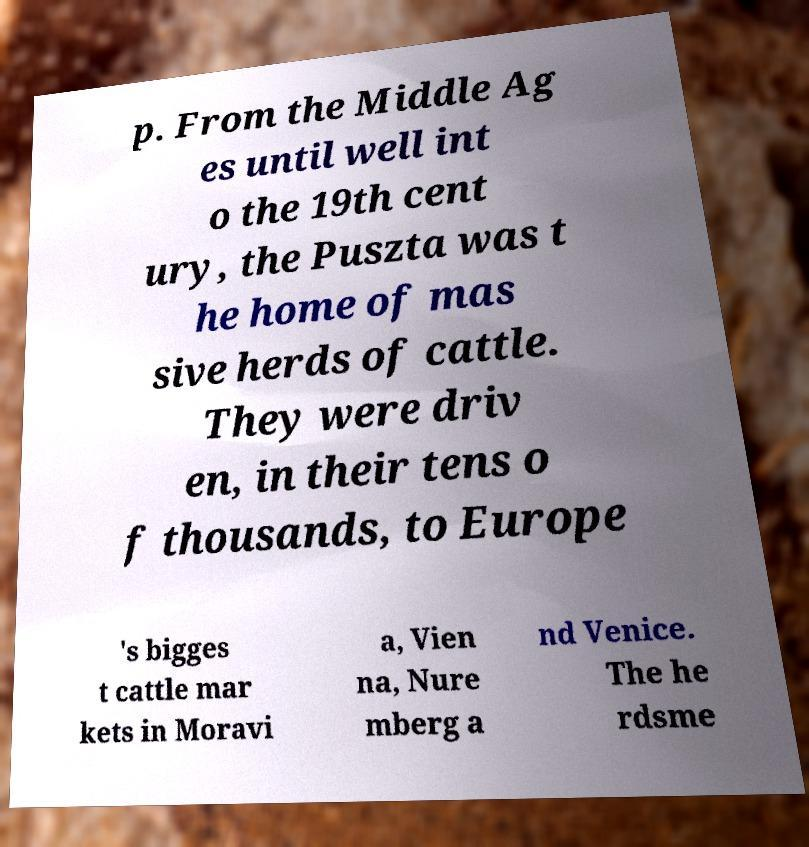I need the written content from this picture converted into text. Can you do that? p. From the Middle Ag es until well int o the 19th cent ury, the Puszta was t he home of mas sive herds of cattle. They were driv en, in their tens o f thousands, to Europe 's bigges t cattle mar kets in Moravi a, Vien na, Nure mberg a nd Venice. The he rdsme 